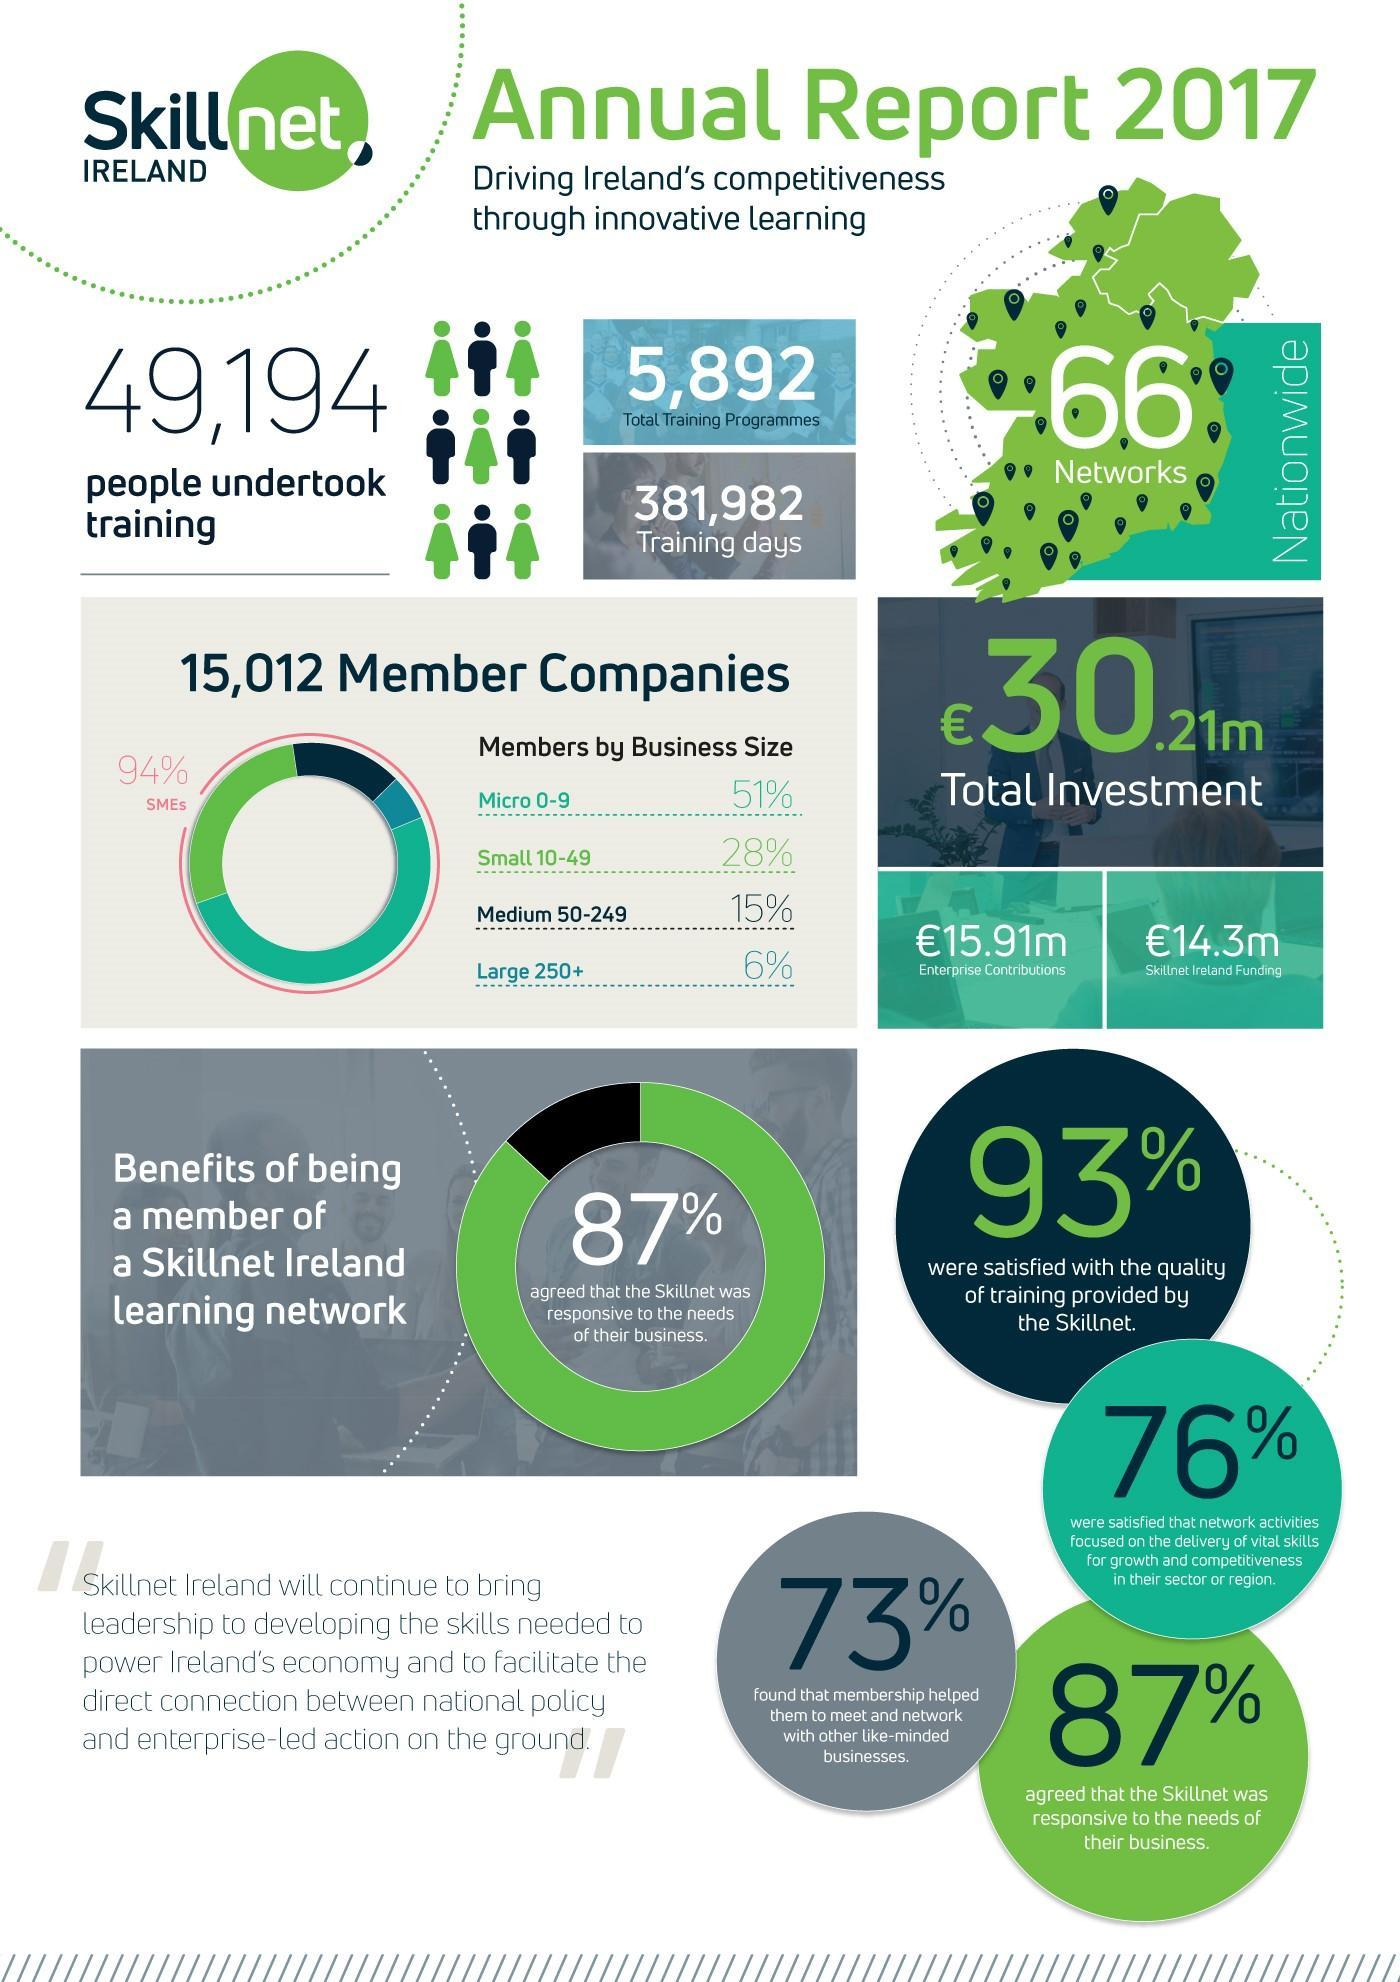What percentage of people were not satisfied with the quality of training provided by the skillnet?
Answer the question with a short phrase. 7% What percentage of people believed that skillnet was irresponsive to the needs of their business? 13% What is the percentage of medium and small when taken together? 43% What percentage of people were not satisfied with the network activities focused on the delivery of vital skills? 24% What is the percentage of micro and small when taken together? 79% 